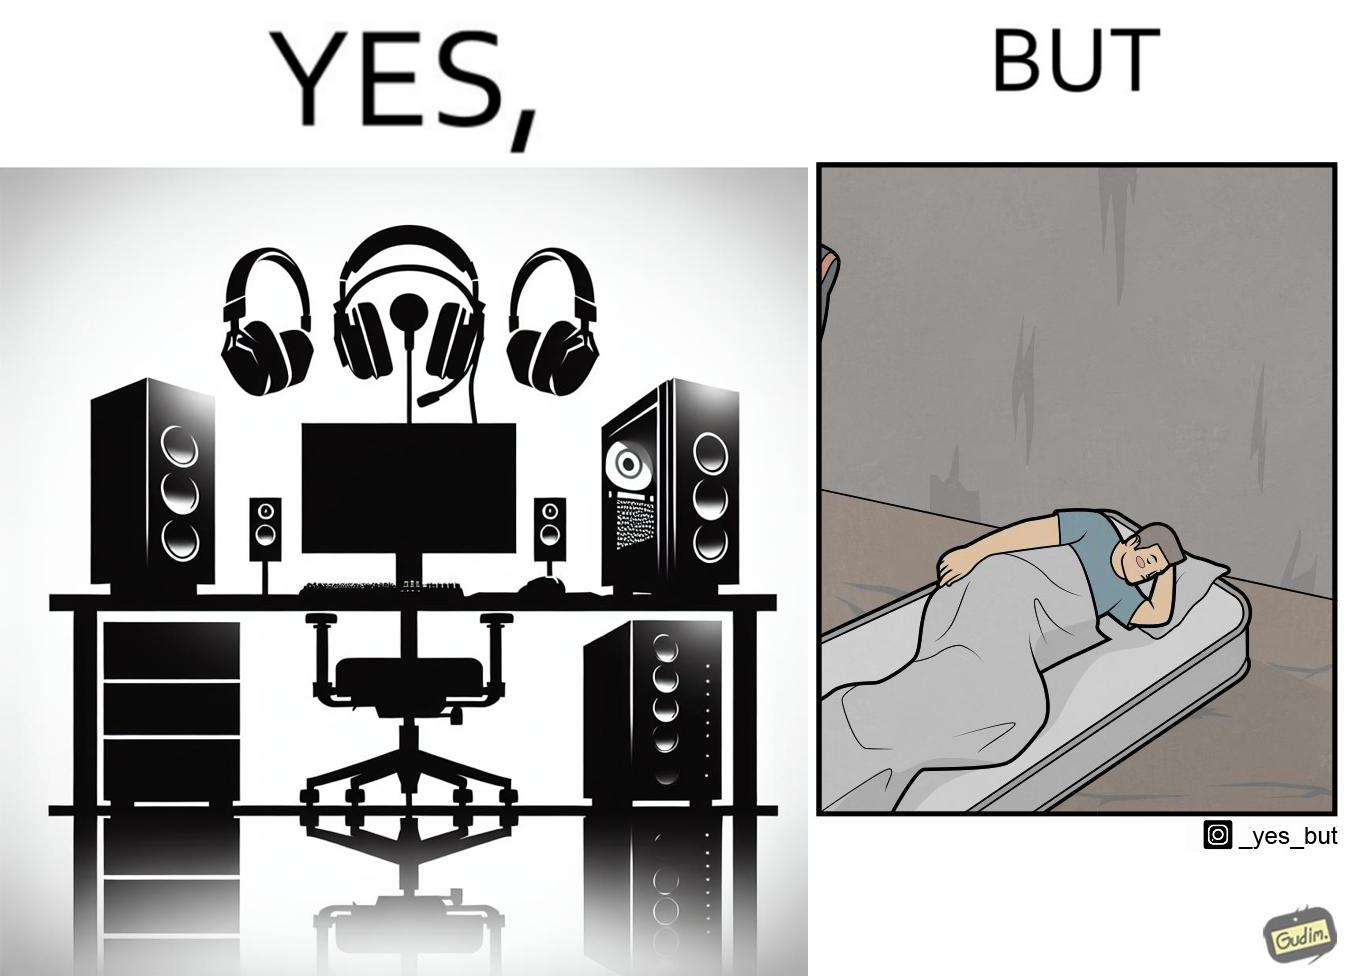What do you see in each half of this image? In the left part of the image: The image shows a computer desk with two monitors, two speakers on the side, a headphone hanging off the side of the table, a cpu on the floor with lights glowing on the front of the cpu and a very comfortable looking gaming chair. The whole setup looks high end and expensive. In the right part of the image: The image shows a man sleeping on a mattress on the floor. There does not seem to be a bedsheet on the mattress. 